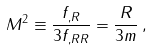<formula> <loc_0><loc_0><loc_500><loc_500>M ^ { 2 } \equiv \frac { f _ { , R } } { 3 f _ { , R R } } = \frac { R } { 3 m } \, ,</formula> 